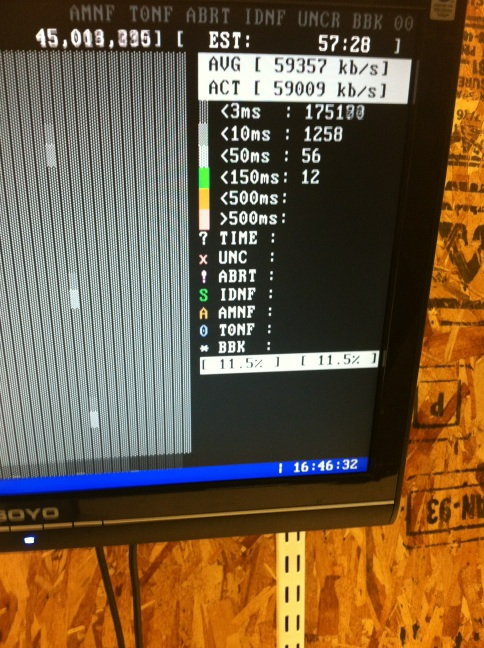What are the current average and actual network speeds displayed on the screen? The screen shows the average network speed as 59357 kb/s and the actual speed as 59009 kb/s. 